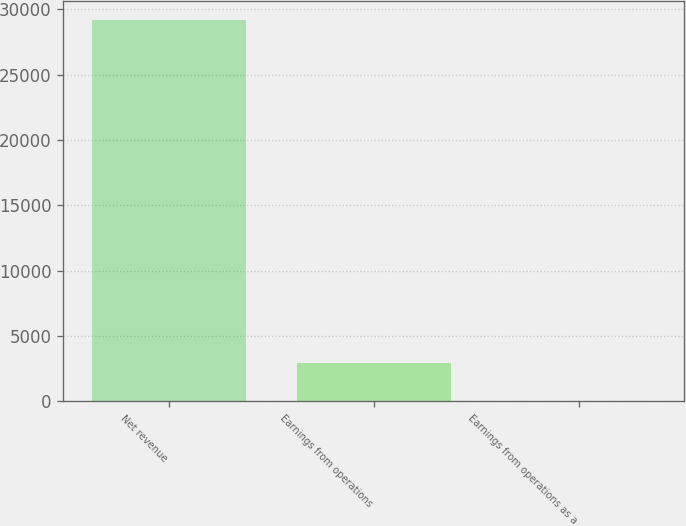Convert chart to OTSL. <chart><loc_0><loc_0><loc_500><loc_500><bar_chart><fcel>Net revenue<fcel>Earnings from operations<fcel>Earnings from operations as a<nl><fcel>29166<fcel>2920.11<fcel>3.9<nl></chart> 